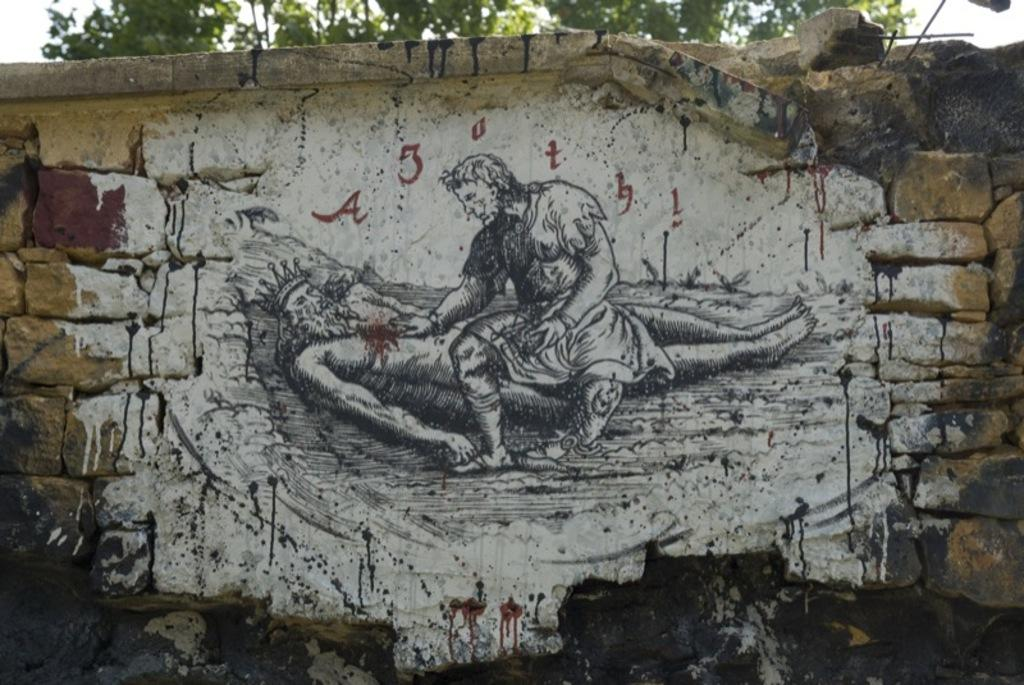What is on the wall in the image? There are paintings and text on the wall in the image. Can you describe the tree visible in the image? The tree is visible in the image, but no specific details about its appearance are provided. What is visible in the background of the image? The sky is visible in the image. How does the tree show its approval in the image? The tree does not show approval in the image, as it is an inanimate object and cannot express emotions or opinions. 